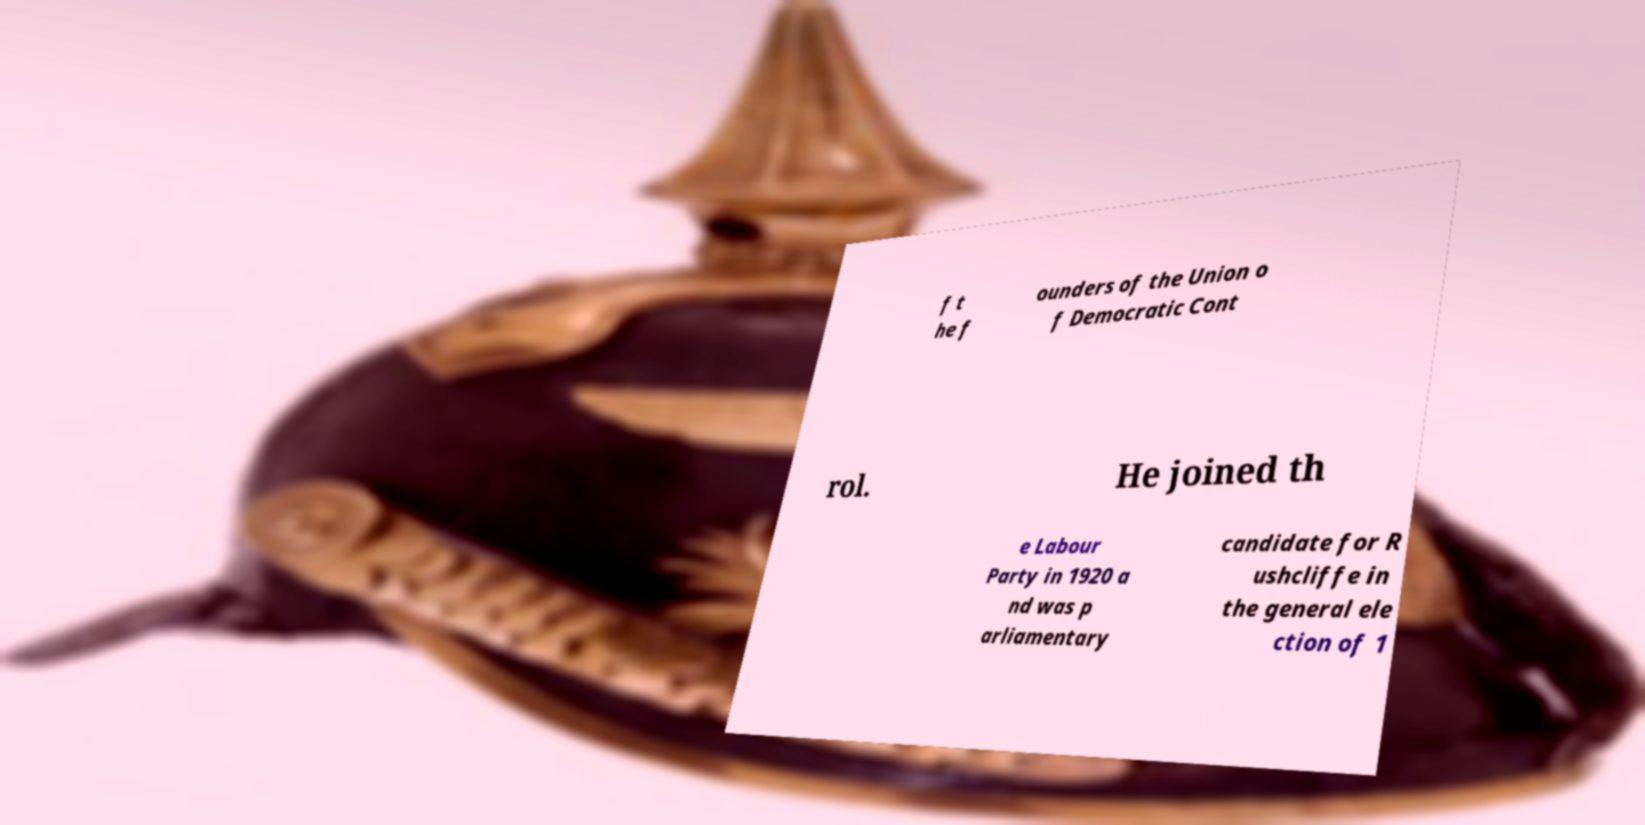Can you read and provide the text displayed in the image?This photo seems to have some interesting text. Can you extract and type it out for me? f t he f ounders of the Union o f Democratic Cont rol. He joined th e Labour Party in 1920 a nd was p arliamentary candidate for R ushcliffe in the general ele ction of 1 